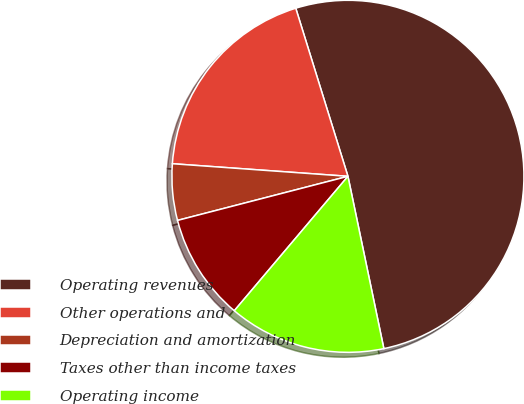<chart> <loc_0><loc_0><loc_500><loc_500><pie_chart><fcel>Operating revenues<fcel>Other operations and<fcel>Depreciation and amortization<fcel>Taxes other than income taxes<fcel>Operating income<nl><fcel>51.52%<fcel>19.07%<fcel>5.17%<fcel>9.8%<fcel>14.44%<nl></chart> 